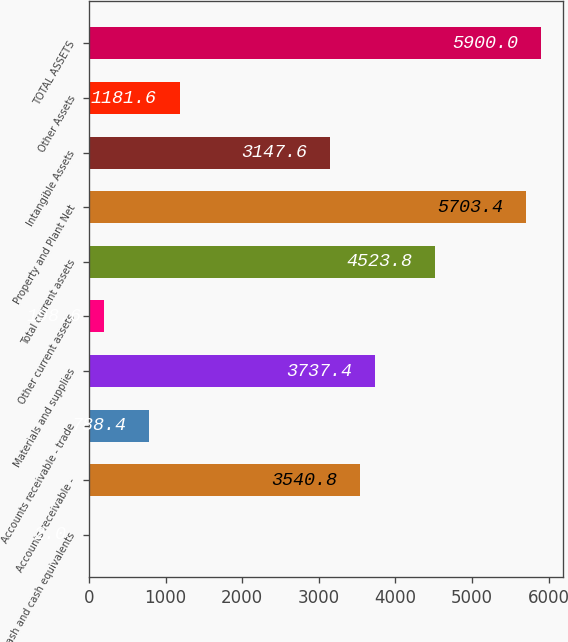<chart> <loc_0><loc_0><loc_500><loc_500><bar_chart><fcel>Cash and cash equivalents<fcel>Accounts receivable -<fcel>Accounts receivable - trade<fcel>Materials and supplies<fcel>Other current assets<fcel>Total current assets<fcel>Property and Plant Net<fcel>Intangible Assets<fcel>Other Assets<fcel>TOTAL ASSETS<nl><fcel>2<fcel>3540.8<fcel>788.4<fcel>3737.4<fcel>198.6<fcel>4523.8<fcel>5703.4<fcel>3147.6<fcel>1181.6<fcel>5900<nl></chart> 